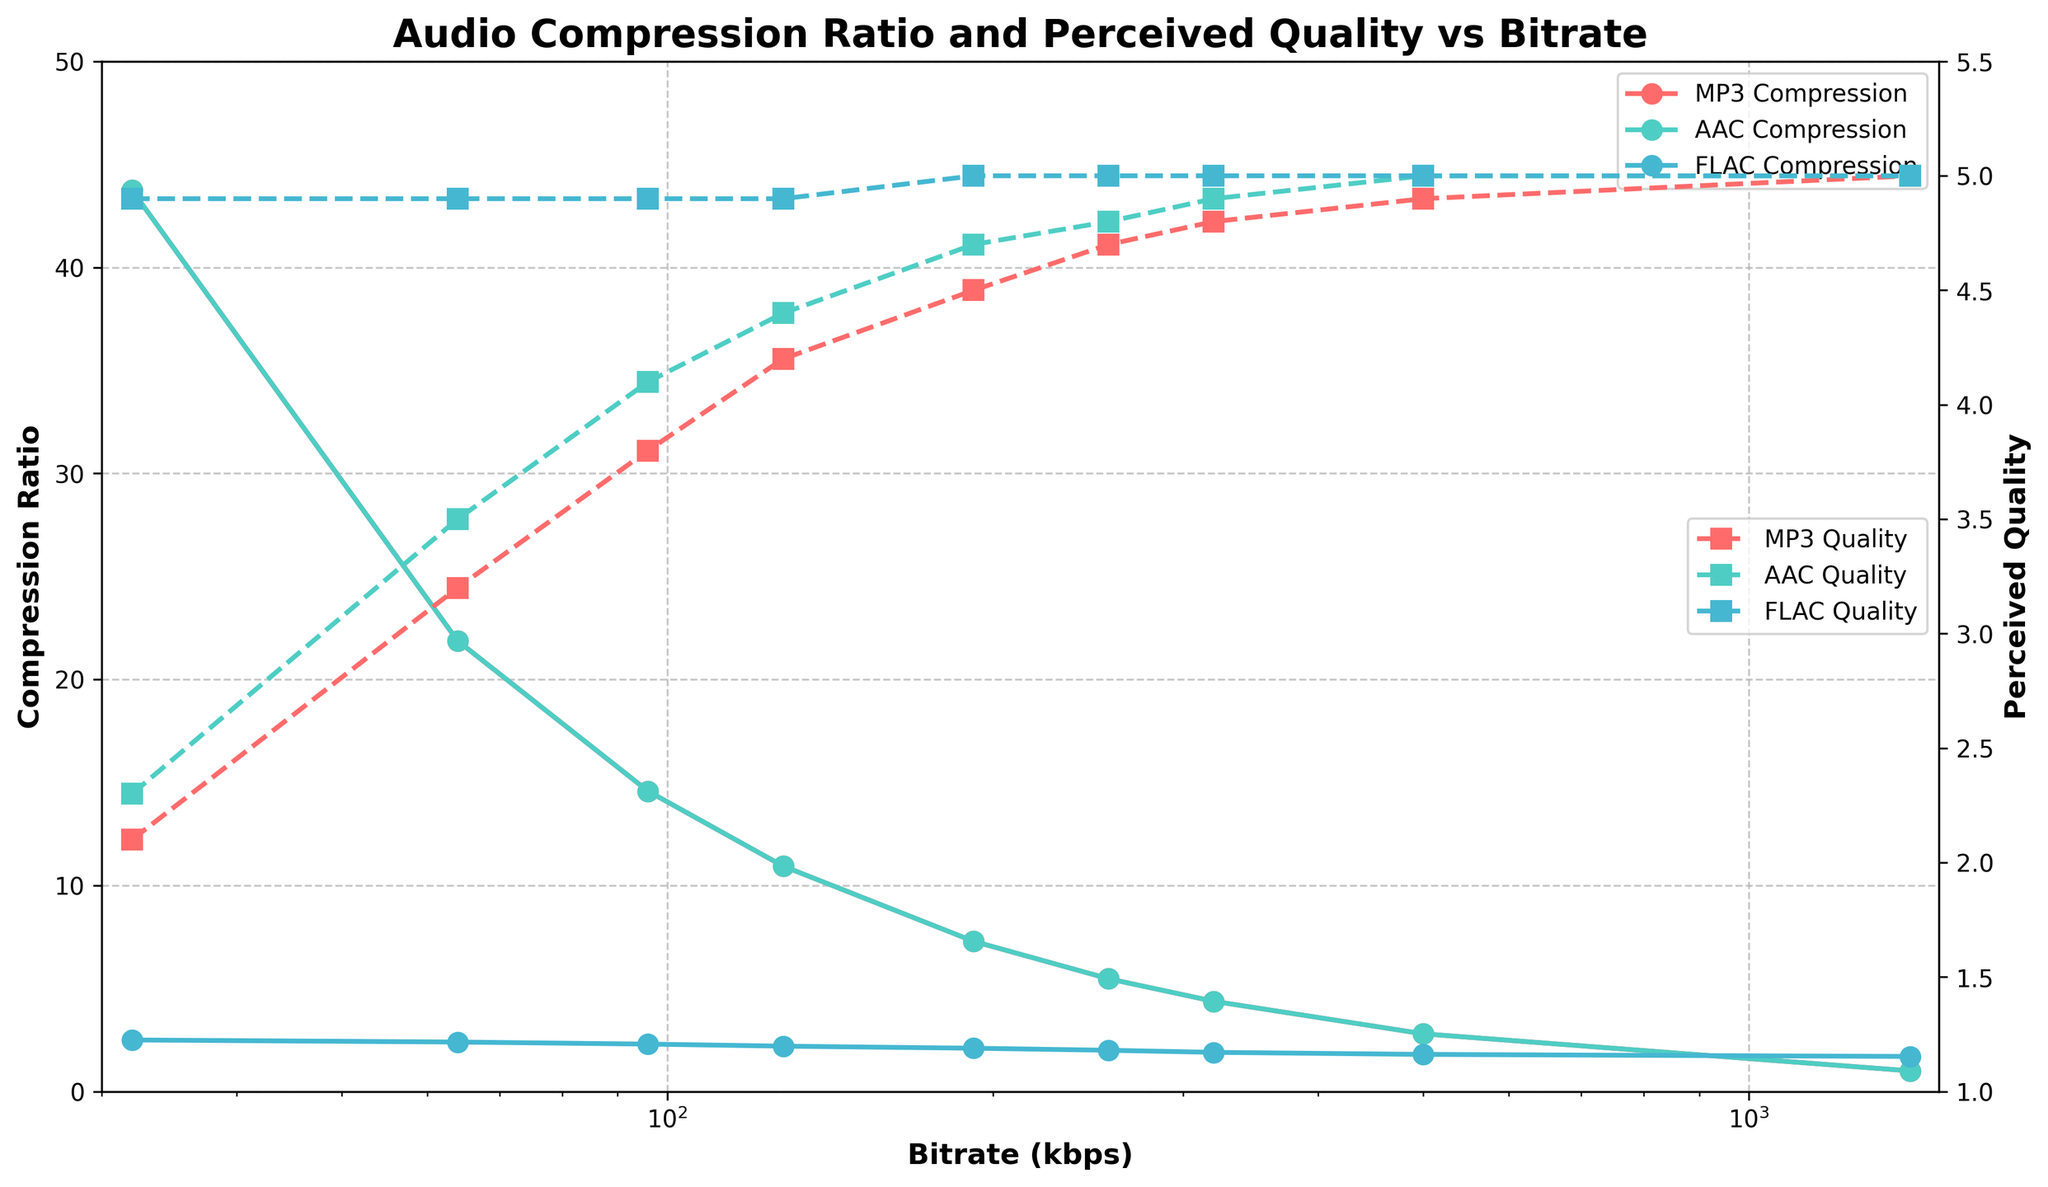What's the compression ratio of MP3 at 128 kbps? To find the compression ratio of MP3 at 128 kbps, look at the line for MP3 Compression and locate the data point at 128 kbps on the x-axis. The y-axis will give you the corresponding compression ratio.
Answer: 10.94 At which bitrate do MP3 and FLAC have the same perceived quality? Comparing the lines for MP3 Perceived Quality and FLAC Perceived Quality, find the point on the x-axis where the two lines have the same value. Both lines reach a perceived quality of 5.0 at 500 kbps.
Answer: 500 kbps Which format has the lowest compression ratio at 64 kbps? To determine which format has the lowest compression ratio at 64 kbps, compare the compression ratios for MP3, AAC, and FLAC at this specific bitrate on the y-axis. FLAC has the lowest compression ratio.
Answer: FLAC How does the perceived quality of AAC change from 32 kbps to 128 kbps? Look at the line for AAC Perceived Quality and compare the y-axis values at 32 kbps and 128 kbps. At 32 kbps, it is 2.3, and at 128 kbps, it is 4.4. The perceived quality increases from 2.3 to 4.4.
Answer: It increases What is the average perceived quality for FLAC across all bitrates? To find this, sum the perceived quality values for FLAC at all bitrates and divide by the number of bitrates. \( \frac{(4.9+4.9+4.9+4.9+5.0+5.0+5.0+5.0+5.0)}{9} = 4.96 \)
Answer: 4.96 At 320 kbps, which format has the highest perceived quality difference from FLAC? Compare the perceived quality values for MP3 and AAC with FLAC at 320 kbps. FLAC's value is 5.0, MP3 is 4.8, and AAC is 4.9. The highest difference is with MP3, which is \(5.0 - 4.8 = 0.2\)
Answer: MP3 In terms of compression ratio, which format shows the least variation across bitrates? Compare the changes in the compression ratios across all bitrates for MP3, AAC, and FLAC lines. FLAC has the least variation, maintaining values closer to a flat line.
Answer: FLAC For which bitrate range is the perceived quality for all formats above 4.0? To determine the bitrate range where perceived quality for all formats is above 4.0, look for the range on the x-axis where the y-axis values for MP3, AAC, and FLAC are all above 4.0. They all cross above 4.0 at bitrates ≥ 128 kbps.
Answer: 128 kbps and above What is the total compression ratio sum of AAC for all bitrates? Sum the AAC Compression ratios: \( 43.75 + 21.88 + 14.58 + 10.94 + 7.29 + 5.47 + 4.38 + 2.80 + 1.00 = 112.09 \).
Answer: 112.09 